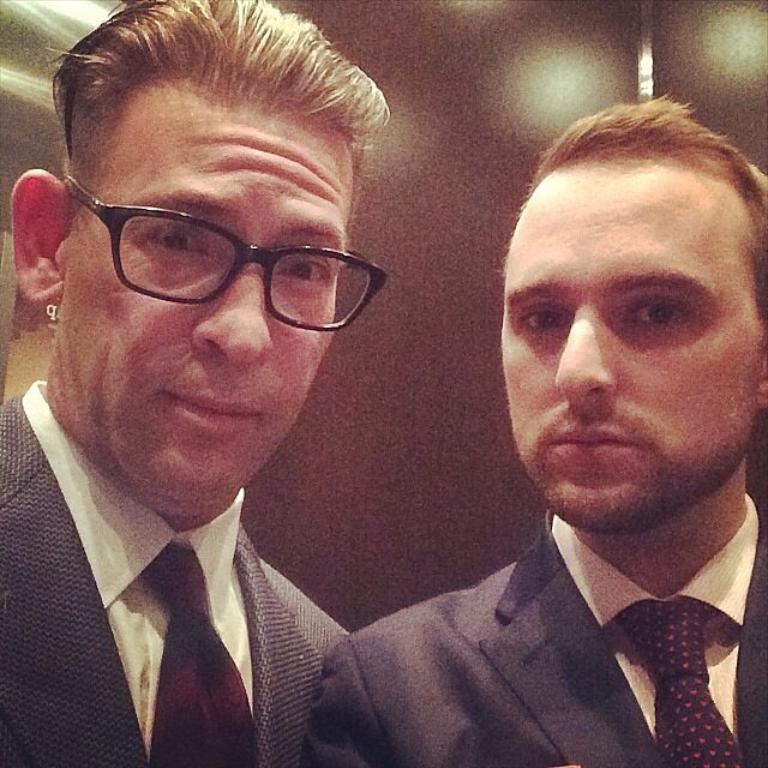What is the setting of the image? The image is likely taken inside a room. How many people are in the image? There are two men in the image. What are the men wearing? The men are wearing black suits. What type of nail is being hammered by one of the men in the image? There is no nail or hammer present in the image; the men are wearing black suits. 